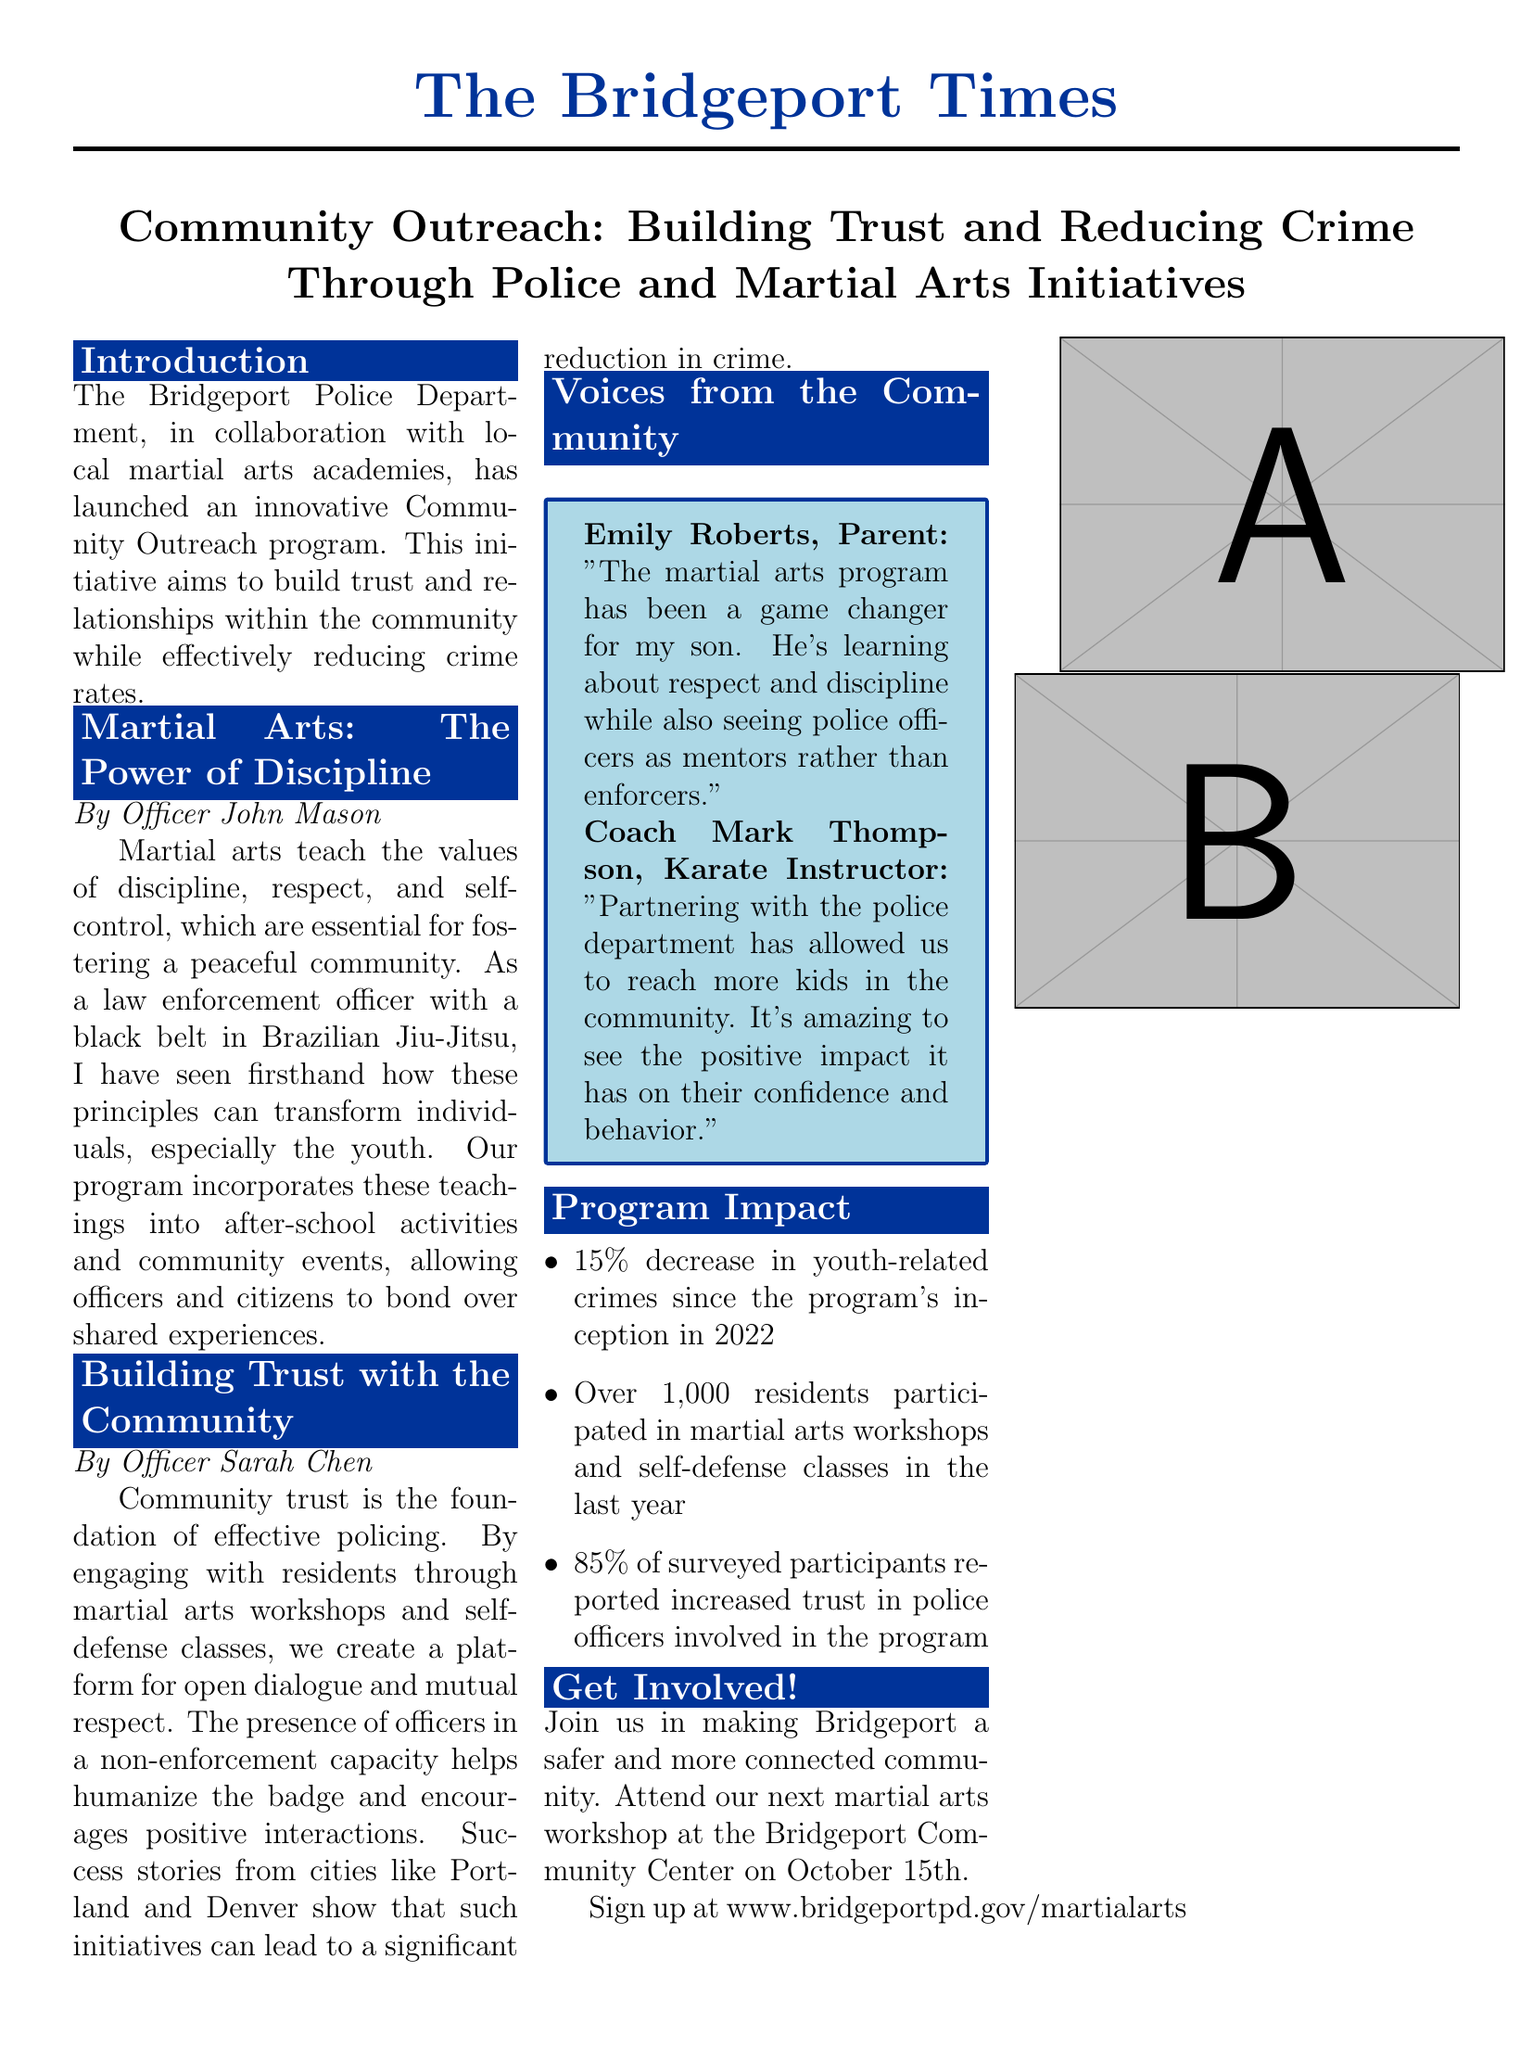What is the name of the newspaper? The title of the newspaper is mentioned at the top of the layout.
Answer: The Bridgeport Times What is the date of the next martial arts workshop? The document provides specific information on the date of the upcoming workshop.
Answer: October 15th How much has youth-related crime decreased since the program started? The program impact section includes statistics on youth-related crimes.
Answer: 15% Who wrote the section on the power of discipline? The author's name is stated under the title of that section.
Answer: Officer John Mason What percentage of surveyed participants reported increased trust in police officers? The program impact statistics highlight participant feedback.
Answer: 85% Which community center is hosting the martial arts workshop? Information on where the workshop will take place is provided in the document.
Answer: Bridgeport Community Center What kind of martial arts is Officer John Mason trained in? The document specifies the type of martial arts that Officer Mason practices.
Answer: Brazilian Jiu-Jitsu Who is quoted as saying the program has been a game changer for their son? The document includes quotes from community members expressing their views.
Answer: Emily Roberts 